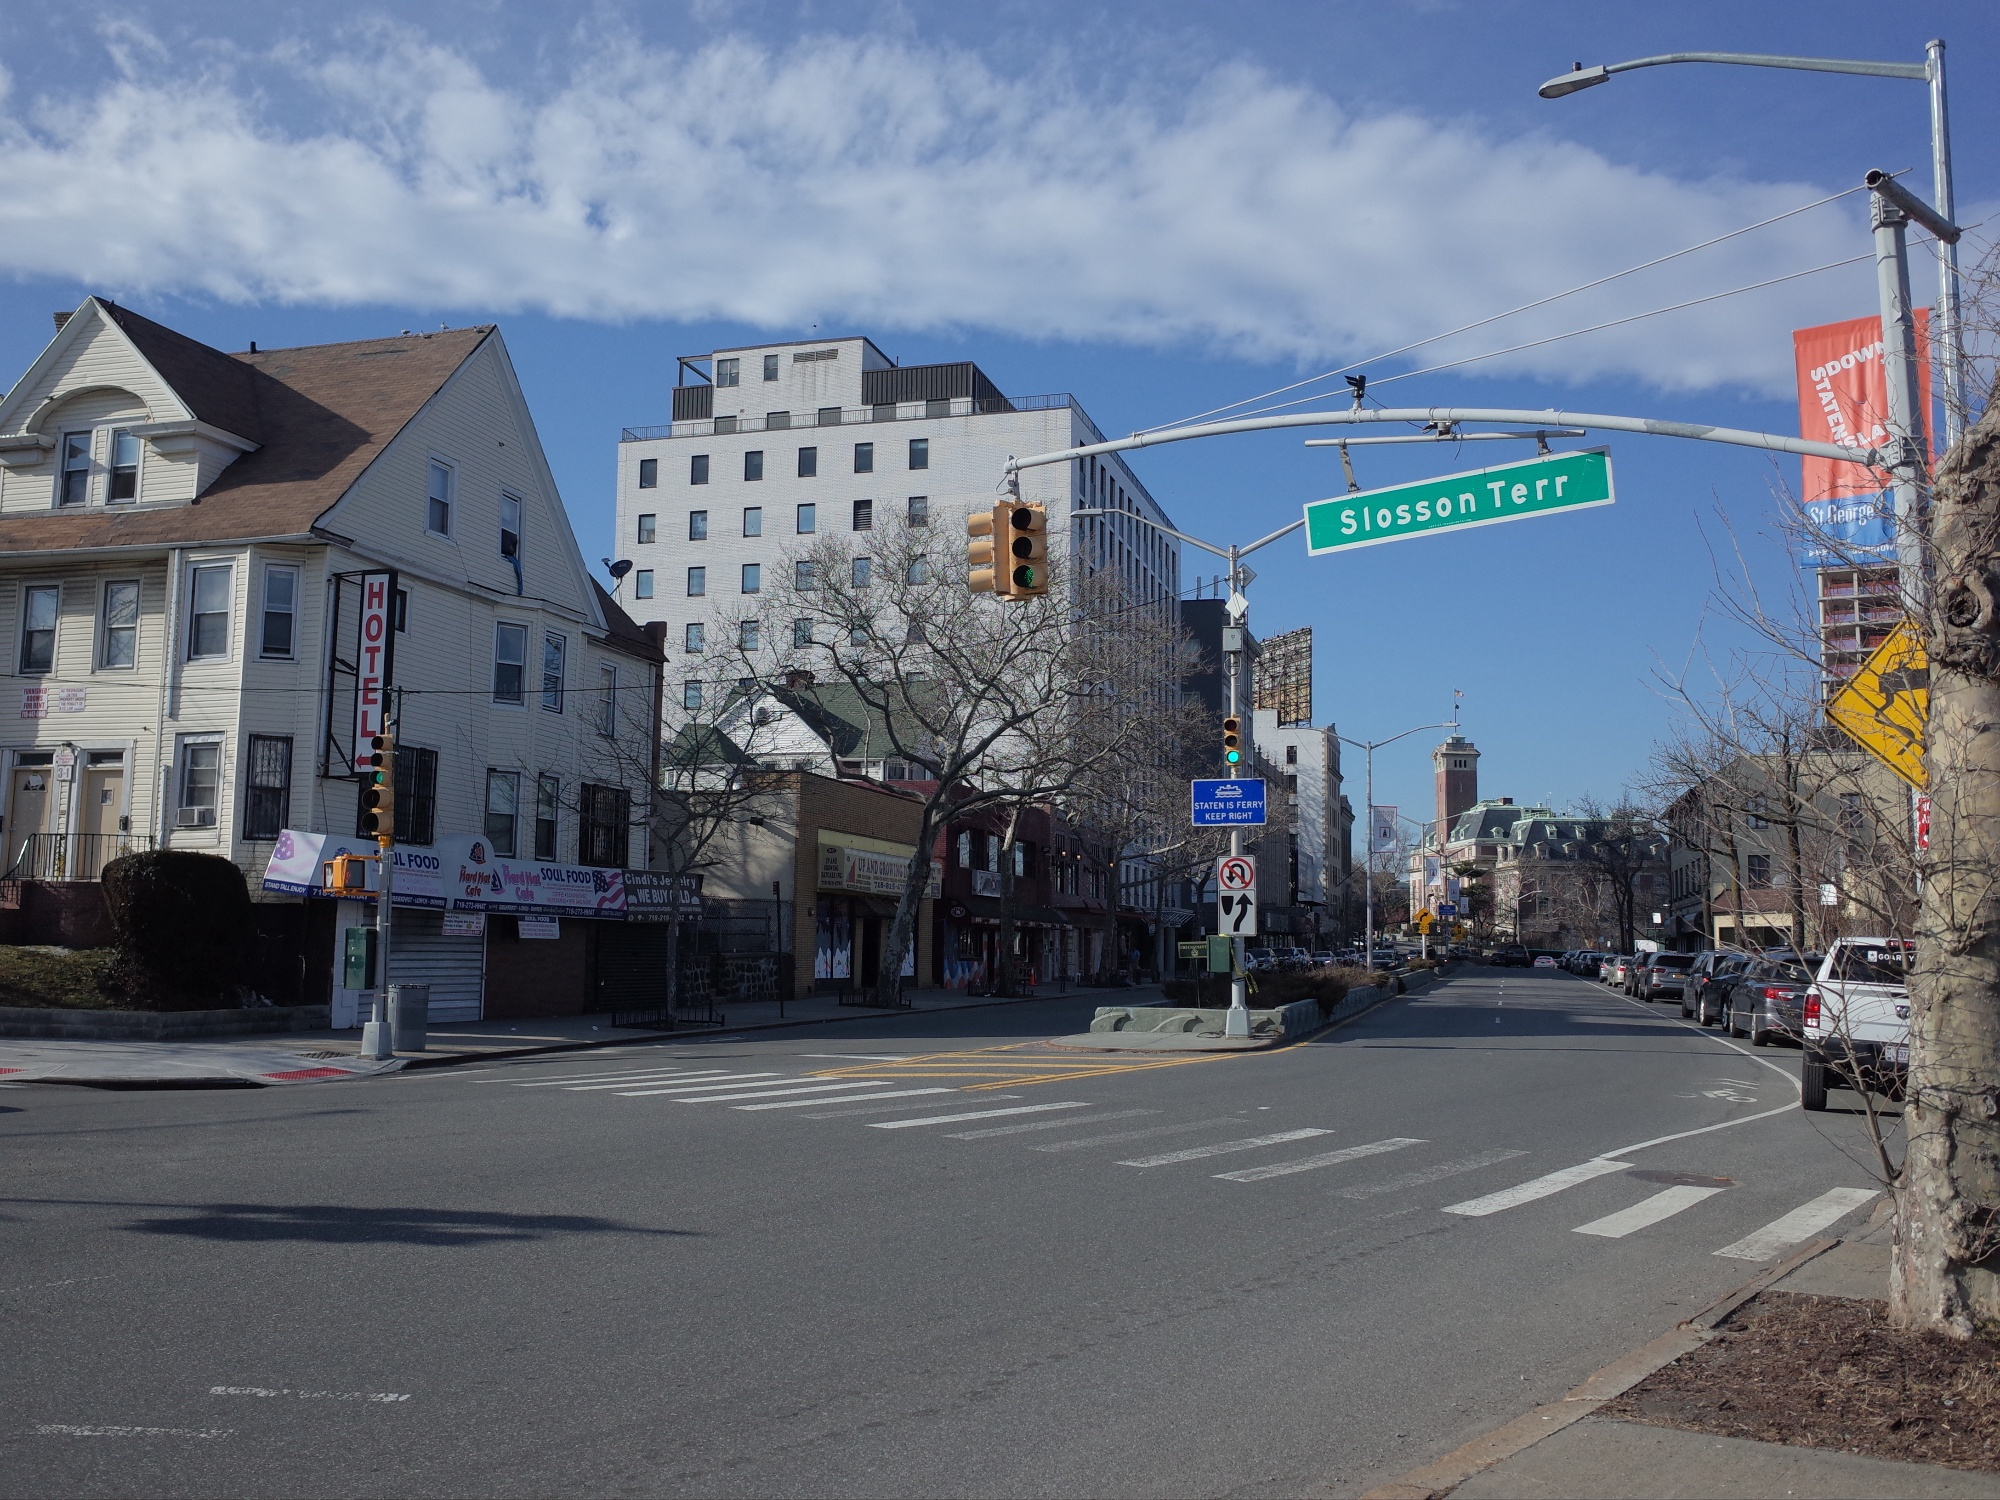What are the key elements in this picture? The image depicts a tranquil urban scene at an intersection. Key elements in the picture include buildings of various architectural styles and sizes, with the most prominent being a white high-rise structure that stands out against the clear blue sky. The street named 'Slosson Terrace' is marked by a sign and bordered by lush trees devoid of any vehicles or pedestrians. A hotel sign can be seen attached to a quaint, tan-colored building on the left side, while the serene atmosphere is complemented by the soft, scattered clouds above. Traffic lights and street signs add to the urban setting, creating a harmonious blend of human construction and natural beauty. 